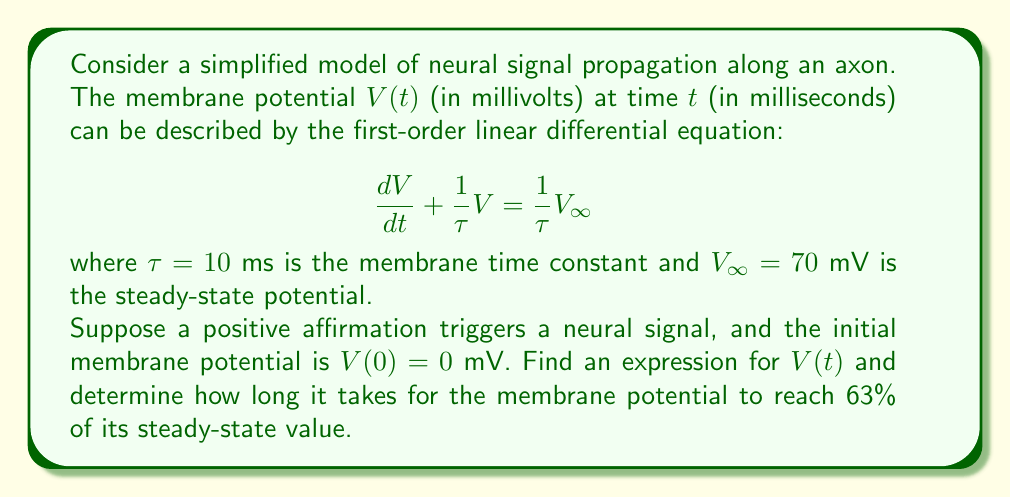What is the answer to this math problem? To solve this problem, we'll follow these steps:

1) First, we need to solve the given differential equation. This is a first-order linear differential equation of the form:

   $$\frac{dV}{dt} + aV = b$$

   where $a = \frac{1}{\tau} = \frac{1}{10}$ and $b = \frac{V_{\infty}}{\tau} = \frac{70}{10} = 7$.

2) The general solution to this equation is:

   $$V(t) = Ce^{-at} + \frac{b}{a}$$

   where $C$ is a constant we'll determine from the initial condition.

3) Substituting the values of $a$ and $b$:

   $$V(t) = Ce^{-t/10} + 70$$

4) To find $C$, we use the initial condition $V(0) = 0$:

   $0 = Ce^{0} + 70$
   $C = -70$

5) Therefore, the specific solution is:

   $$V(t) = 70(1 - e^{-t/10})$$

6) To find when the potential reaches 63% of its steady-state value, we solve:

   $V(t) = 0.63V_{\infty} = 0.63 \cdot 70 = 44.1$

   $44.1 = 70(1 - e^{-t/10})$
   $0.63 = 1 - e^{-t/10}$
   $e^{-t/10} = 0.37$
   $-t/10 = \ln(0.37)$
   $t = -10\ln(0.37) \approx 10$ ms
Answer: The membrane potential as a function of time is given by:

$$V(t) = 70(1 - e^{-t/10})$$ mV

It takes approximately 10 ms for the membrane potential to reach 63% of its steady-state value. 